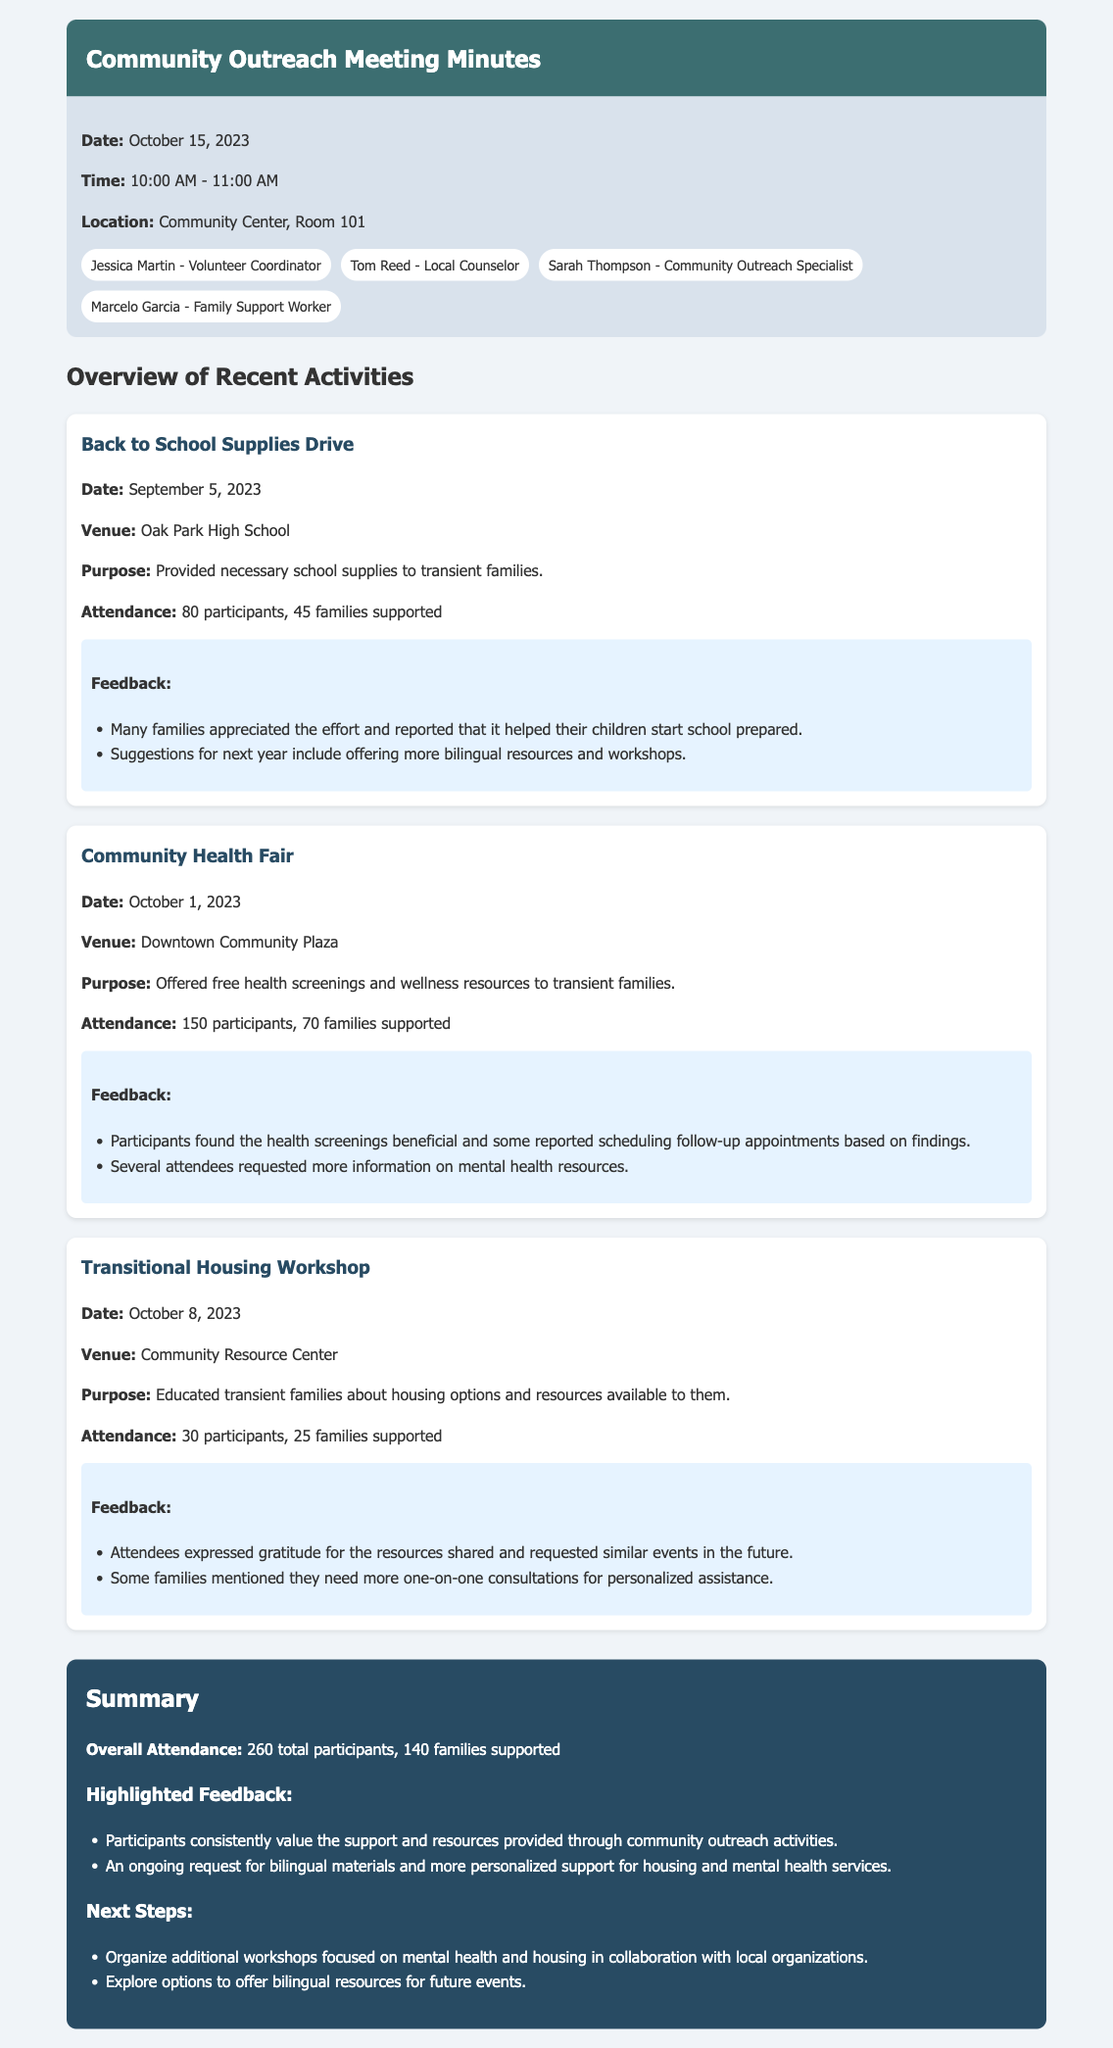what is the date of the meeting? The date of the meeting is specified in the meeting information section of the document.
Answer: October 15, 2023 how many families were supported during the Back to School Supplies Drive? The number of families supported is listed under the attendance metrics for each event.
Answer: 45 families what was the attendance for the Community Health Fair? The attendance for the event is stated in the overview of the specific event.
Answer: 150 participants what feedback did participants provide for the Transitional Housing Workshop? The feedback for the event is summarized in bullet points under each event, indicating participants' responses.
Answer: Attendees expressed gratitude for the resources shared how many total participants were there across all events? The total number of participants is summarized in the summary section of the document, aggregating all events.
Answer: 260 total participants what suggestion was made for future events across multiple activities? Suggestions for improvement can be found within the feedback sections for each event, reflecting participants' common requests.
Answer: Offering more bilingual resources what is the purpose of the Community Health Fair? The purpose of each event is outlined in a dedicated section under each event description.
Answer: Offered free health screenings and wellness resources who organized the Back to School Supplies Drive? The context and responsibilities of participants are often noted in the meeting header or the overview sections.
Answer: Not specified in the document how many families were supported in the Transitional Housing Workshop? The number of families supported is specifically indicated for each event within the attendance metrics.
Answer: 25 families 